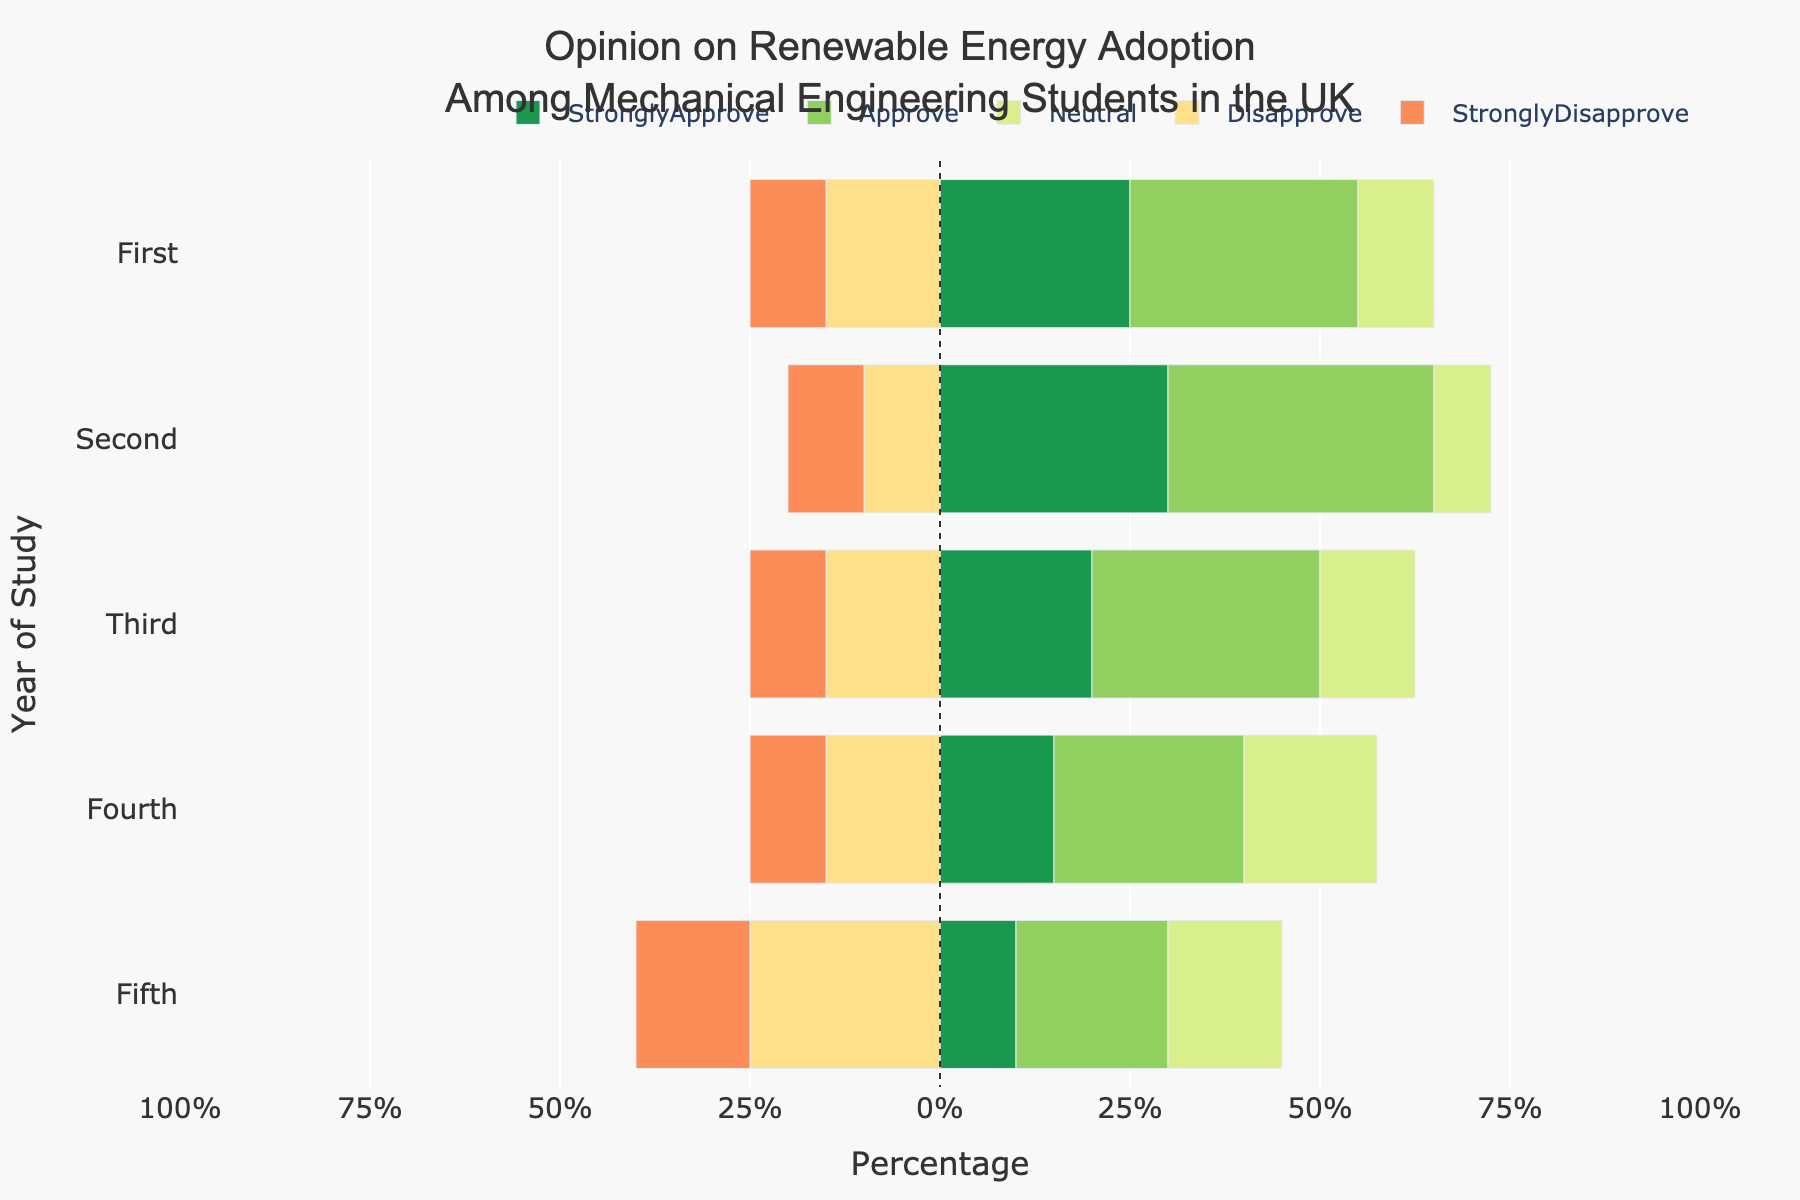What is the most common opinion among first-year students? The bar representing the 'Approve' category for first-year students is the longest in the positive direction, indicating it's the most common opinion.
Answer: Approve Which year of study has the highest percentage of students who strongly disapprove? The fifth-year students have the longest bar in the negative direction for the 'StronglyDisapprove' category, indicating it's the highest.
Answer: Fifth Which year has the highest combined percentage of students who either strongly approve or approve? First, add 'StronglyApprove' and 'Approve' values for each year: First (25+30=55%), Second (30+35=65%), Third (20+30=50%), Fourth (15+25=40%), Fifth (10+20=30%). The second-year students have the highest combined percentage.
Answer: Second How does the neutral opinion change from the first year to the fifth year? The neutral opinion percentage increases from 20% in the first year to 30% in the fifth year, indicating a 10% rise.
Answer: Increases by 10% Which year of study has the smallest percentage of students who disapprove? Compare the 'Disapprove' percentages; second and third-year students have the lowest percentage at 10%.
Answer: Second and Third What is the sum of strongly disapprove and disapprove percentages for fourth-year students? Add 'StronglyDisapprove' and 'Disapprove' values for fourth-year students: 10% (StronglyDisapprove) + 15% (Disapprove) = 25%.
Answer: 25% Is there any year where the neutral opinion is the highest compared to other opinions? For fourth-year students, the 'Neutral' opinion has the highest percentage compared to others, indicated by the longest bar towards the middle.
Answer: Fourth Which year has the closest percentage between approve and neutral opinions? Compare the 'Approve' and 'Neutral' bars for each year: Third year has 'Approve' (30%) and 'Neutral' (25%), with a difference of 5%. This is the closest.
Answer: Third What percentage of fifth-year students either approve or are neutral? Sum the 'Approve' and 'Neutral' values for fifth-year students: 20% (Approve) + 30% (Neutral) = 50%.
Answer: 50% Which year shows the least support for renewable energy adoption (sum of disapprove and strongly disapprove)? Calculate the sum of 'Disapprove' and 'StronglyDisapprove' for each year: First (15+10=25%), Second (10+10=20%), Third (15+10=25%), Fourth (15+10=25%), Fifth (25+15=40%). Fifth year has the highest combined disapproval percentage.
Answer: Fifth 